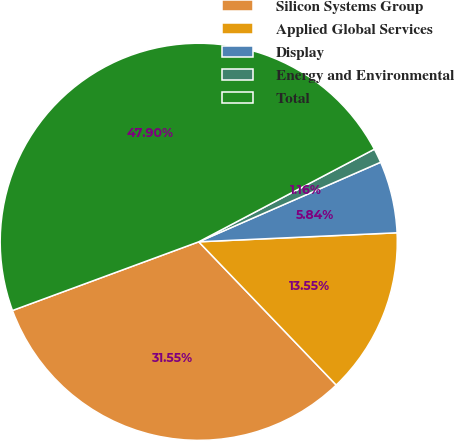Convert chart to OTSL. <chart><loc_0><loc_0><loc_500><loc_500><pie_chart><fcel>Silicon Systems Group<fcel>Applied Global Services<fcel>Display<fcel>Energy and Environmental<fcel>Total<nl><fcel>31.55%<fcel>13.55%<fcel>5.84%<fcel>1.16%<fcel>47.9%<nl></chart> 